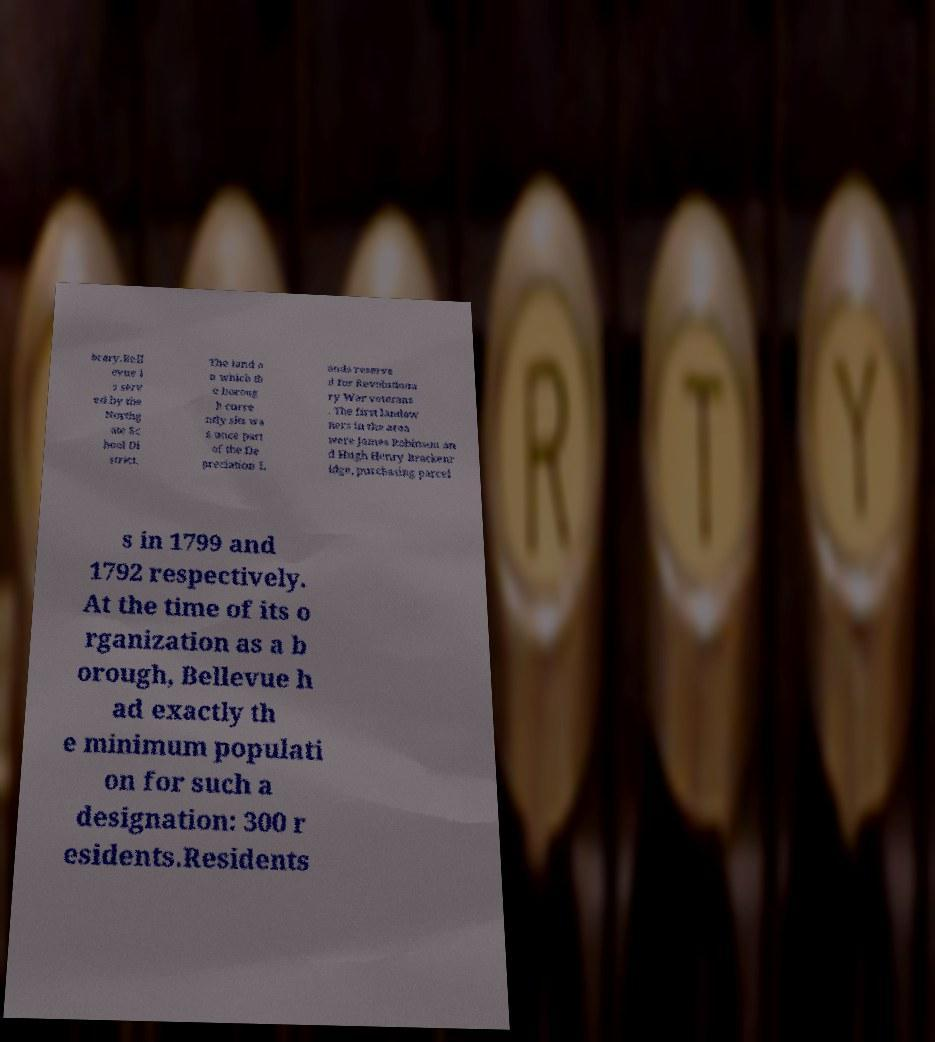Can you read and provide the text displayed in the image?This photo seems to have some interesting text. Can you extract and type it out for me? brary.Bell evue i s serv ed by the Northg ate Sc hool Di strict. The land o n which th e boroug h curre ntly sits wa s once part of the De preciation L ands reserve d for Revolutiona ry War veterans . The first landow ners in the area were James Robinson an d Hugh Henry Brackenr idge, purchasing parcel s in 1799 and 1792 respectively. At the time of its o rganization as a b orough, Bellevue h ad exactly th e minimum populati on for such a designation: 300 r esidents.Residents 